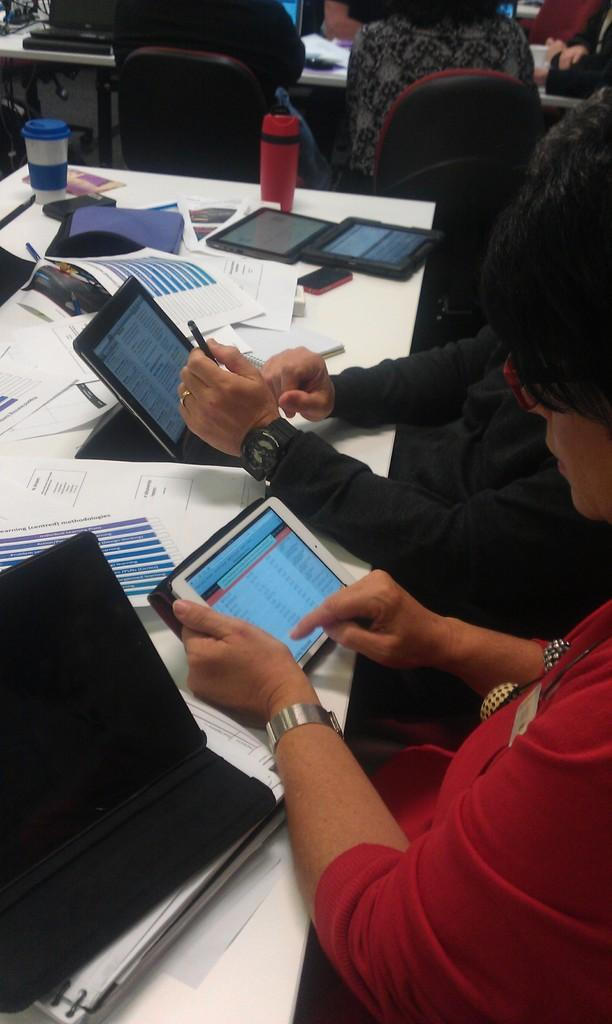What electronic devices are visible in the image? There are iPads in the image. What type of reading materials can be seen in the image? There are papers and books in the image. What communication device is present in the image? There is a mobile in the image. What beverage container is visible in the image? There is a bottle in the image. What other objects are present on the table in the image? There are other objects on the table, but their specific details are not mentioned in the provided facts. Can you describe the people in the image? There is a group of people sitting on chairs in the image. How many sisters are sitting on the chairs in the image? There is no mention of sisters in the image, and the provided facts do not indicate the presence of any family members. What type of lumber is being used to build the table in the image? The provided facts do not mention any construction materials or furniture-related details. 